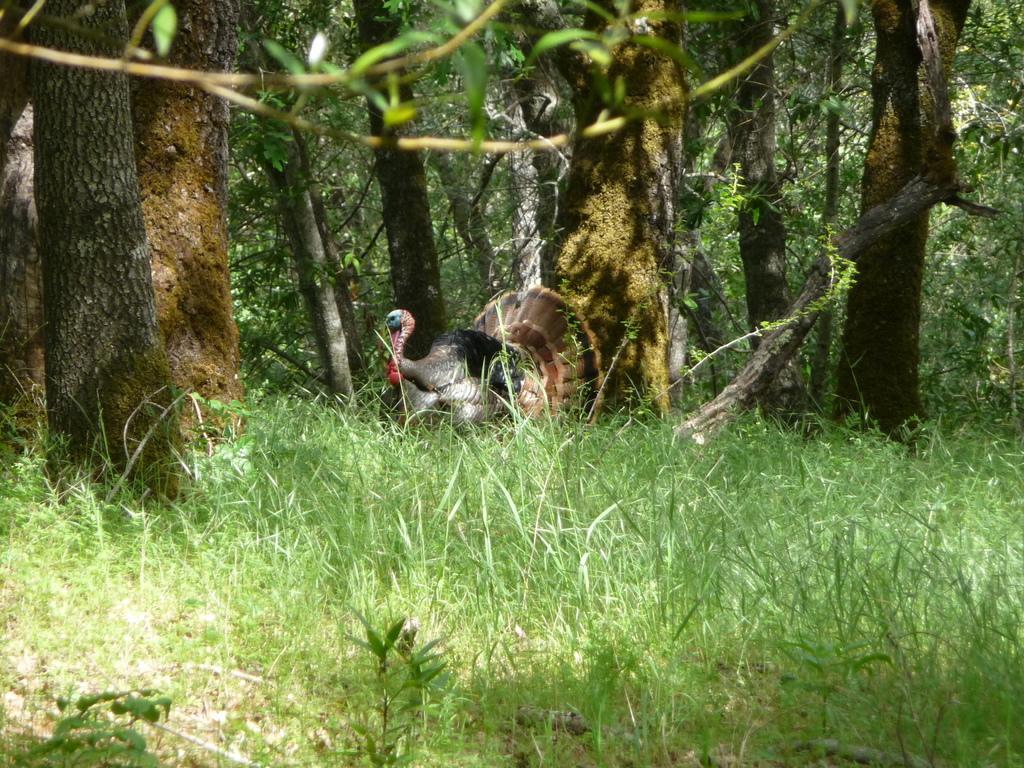Describe this image in one or two sentences. There are plants and grass on the ground. In the background, there is a peacock and there are trees on the ground. 